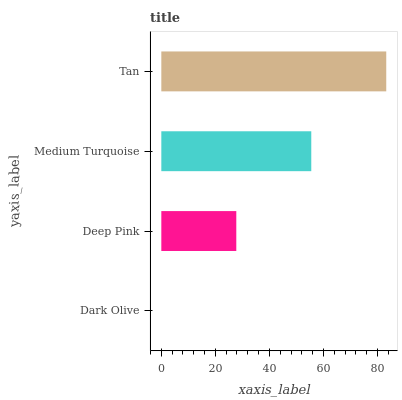Is Dark Olive the minimum?
Answer yes or no. Yes. Is Tan the maximum?
Answer yes or no. Yes. Is Deep Pink the minimum?
Answer yes or no. No. Is Deep Pink the maximum?
Answer yes or no. No. Is Deep Pink greater than Dark Olive?
Answer yes or no. Yes. Is Dark Olive less than Deep Pink?
Answer yes or no. Yes. Is Dark Olive greater than Deep Pink?
Answer yes or no. No. Is Deep Pink less than Dark Olive?
Answer yes or no. No. Is Medium Turquoise the high median?
Answer yes or no. Yes. Is Deep Pink the low median?
Answer yes or no. Yes. Is Tan the high median?
Answer yes or no. No. Is Medium Turquoise the low median?
Answer yes or no. No. 